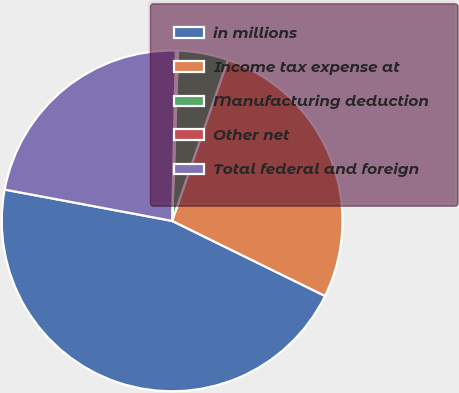<chart> <loc_0><loc_0><loc_500><loc_500><pie_chart><fcel>in millions<fcel>Income tax expense at<fcel>Manufacturing deduction<fcel>Other net<fcel>Total federal and foreign<nl><fcel>45.68%<fcel>26.96%<fcel>4.75%<fcel>0.2%<fcel>22.41%<nl></chart> 